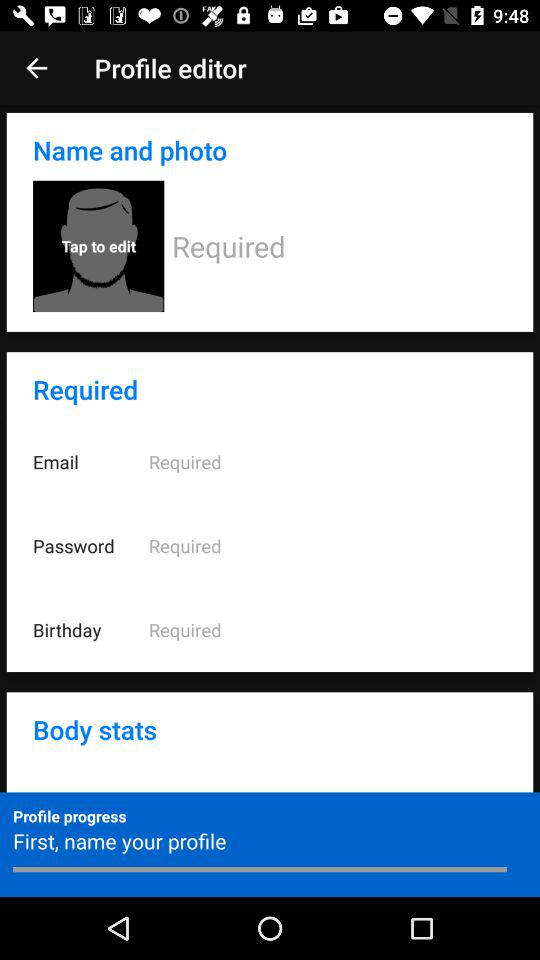How many required fields are there in the profile editor?
Answer the question using a single word or phrase. 4 